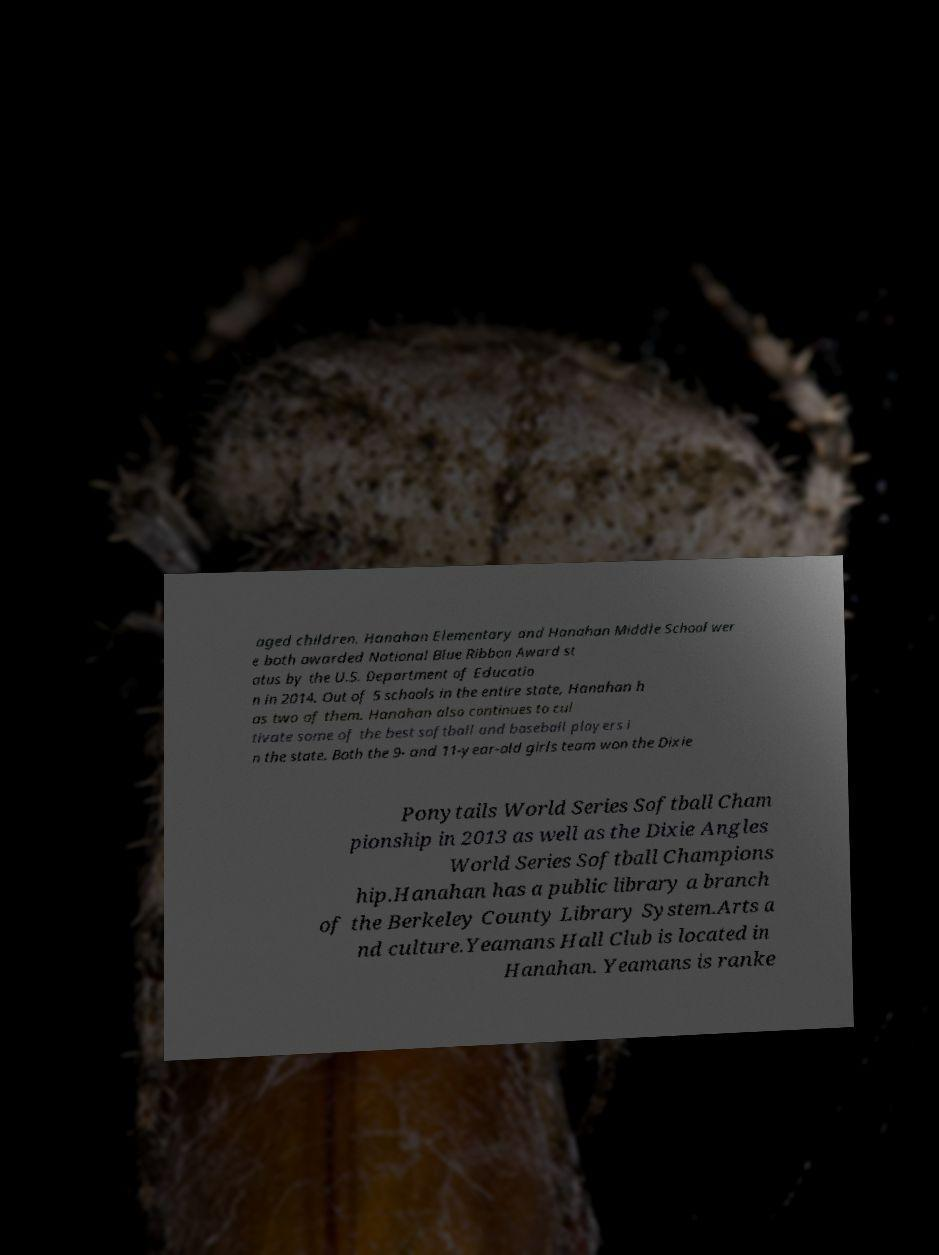I need the written content from this picture converted into text. Can you do that? aged children. Hanahan Elementary and Hanahan Middle School wer e both awarded National Blue Ribbon Award st atus by the U.S. Department of Educatio n in 2014. Out of 5 schools in the entire state, Hanahan h as two of them. Hanahan also continues to cul tivate some of the best softball and baseball players i n the state. Both the 9- and 11-year-old girls team won the Dixie Ponytails World Series Softball Cham pionship in 2013 as well as the Dixie Angles World Series Softball Champions hip.Hanahan has a public library a branch of the Berkeley County Library System.Arts a nd culture.Yeamans Hall Club is located in Hanahan. Yeamans is ranke 